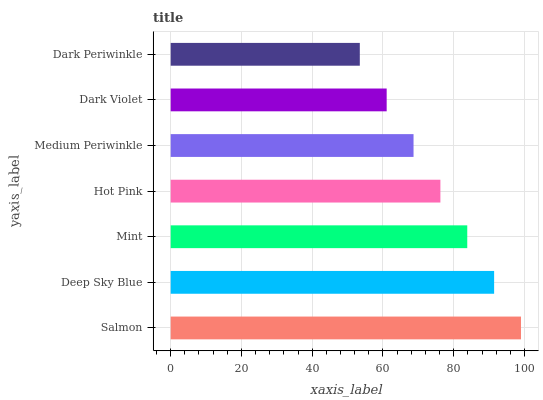Is Dark Periwinkle the minimum?
Answer yes or no. Yes. Is Salmon the maximum?
Answer yes or no. Yes. Is Deep Sky Blue the minimum?
Answer yes or no. No. Is Deep Sky Blue the maximum?
Answer yes or no. No. Is Salmon greater than Deep Sky Blue?
Answer yes or no. Yes. Is Deep Sky Blue less than Salmon?
Answer yes or no. Yes. Is Deep Sky Blue greater than Salmon?
Answer yes or no. No. Is Salmon less than Deep Sky Blue?
Answer yes or no. No. Is Hot Pink the high median?
Answer yes or no. Yes. Is Hot Pink the low median?
Answer yes or no. Yes. Is Mint the high median?
Answer yes or no. No. Is Dark Periwinkle the low median?
Answer yes or no. No. 